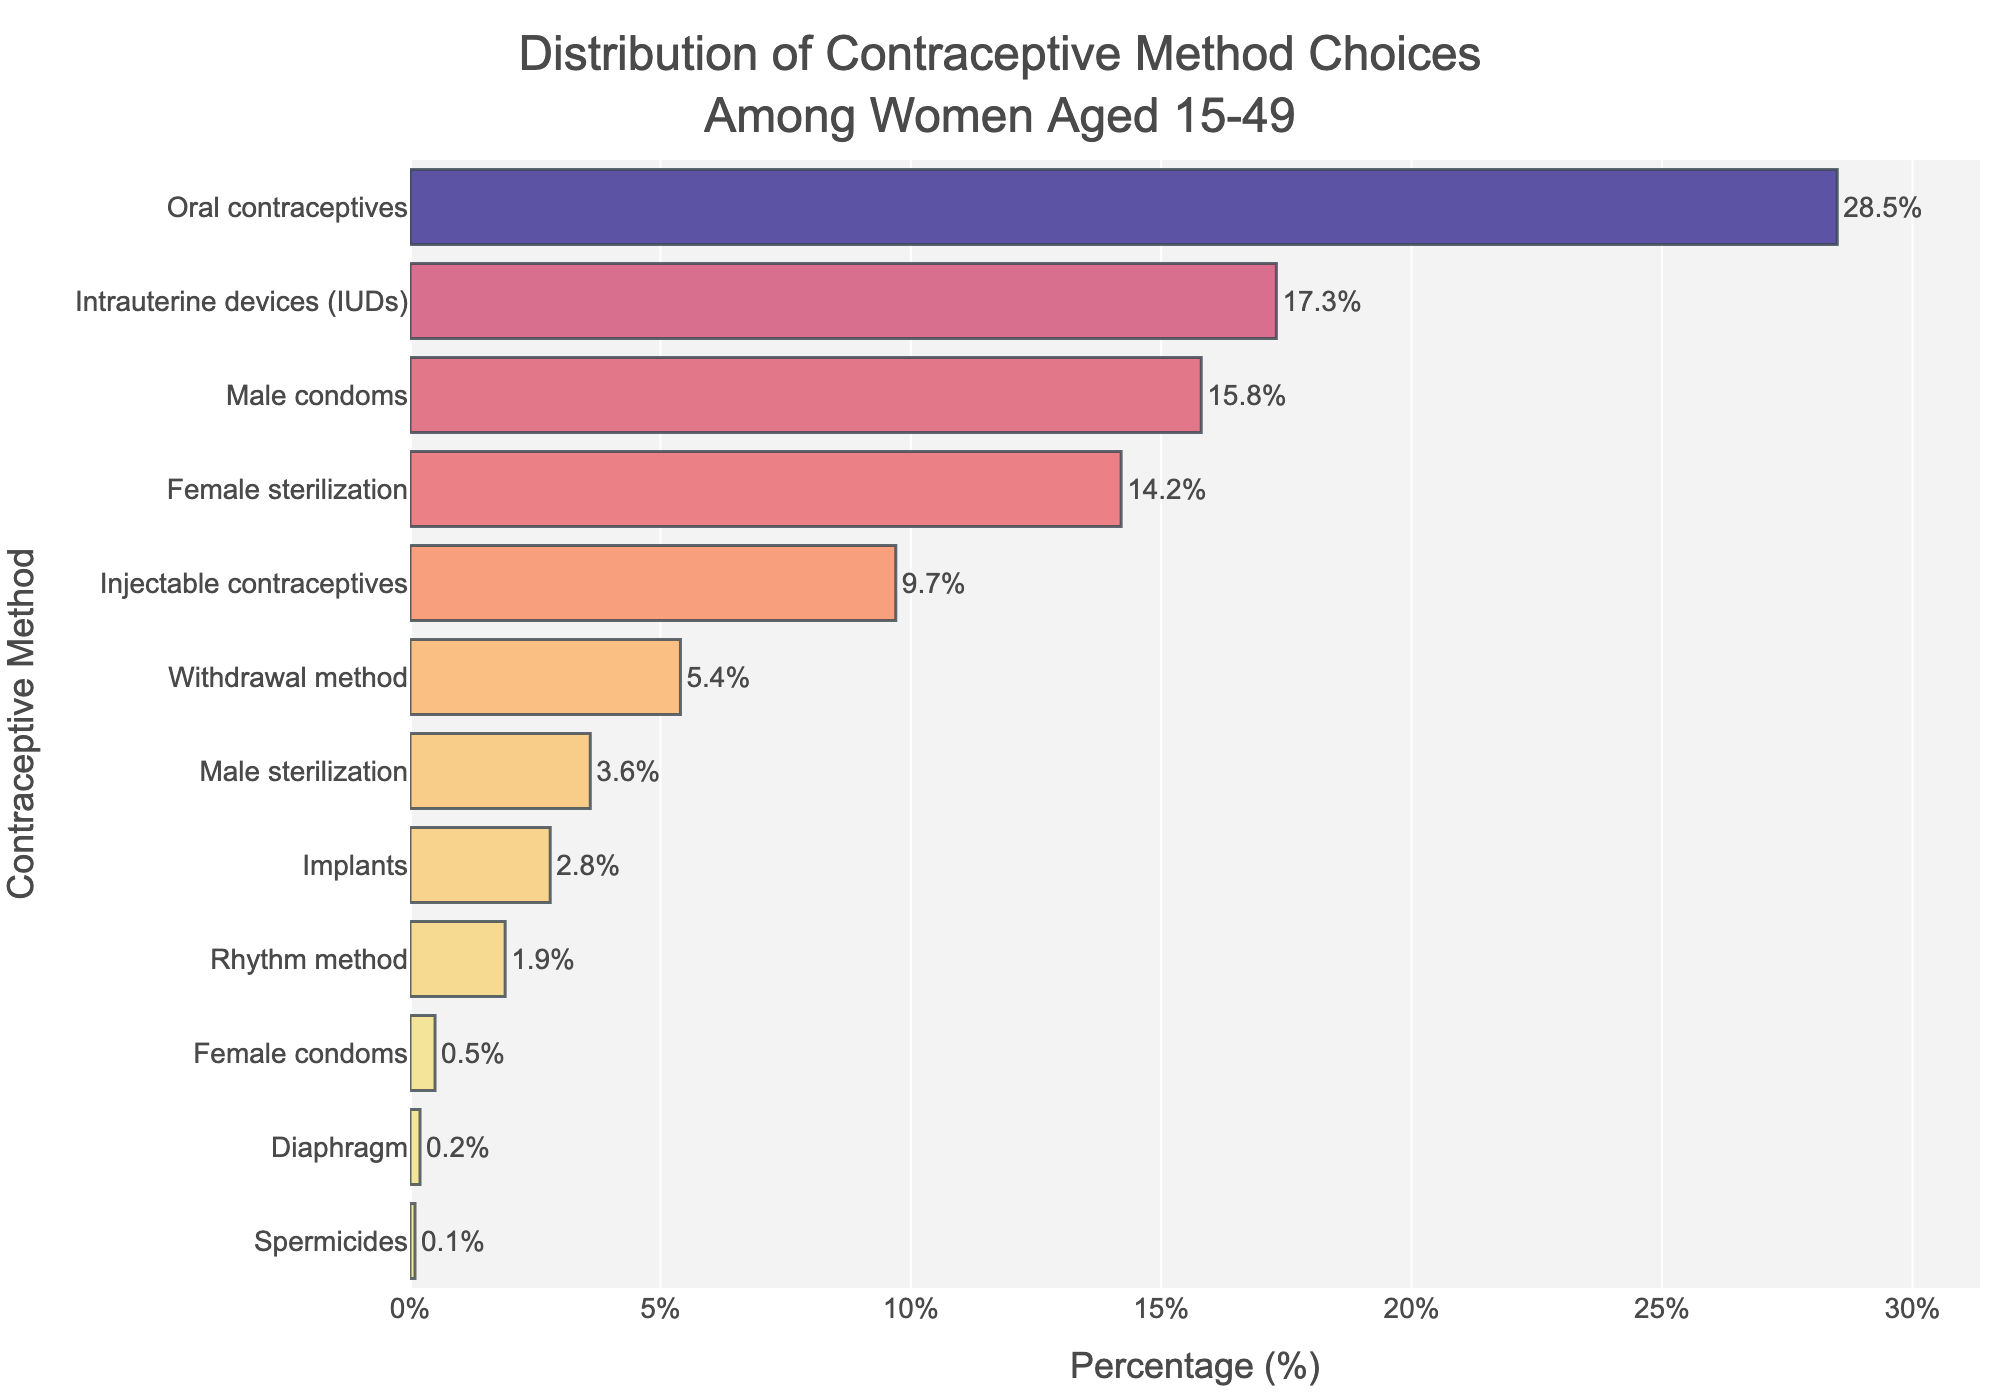Which contraceptive method is chosen by the highest percentage of women aged 15-49? The bar that reaches the farthest to the right indicates the contraceptive method chosen by the highest percentage of women. According to the chart, oral contraceptives have the highest percentage at 28.5%.
Answer: Oral contraceptives Which contraceptive method has a higher percentage of users, injectable contraceptives or intrauterine devices (IUDs)? The bar representing intrauterine devices (IUDs) is longer than the bar for injectable contraceptives. According to the chart, IUDs have 17.3% while injectable contraceptives have 9.7%.
Answer: Intrauterine devices (IUDs) What is the combined percentage of women using female sterilization, implants, and rhythm method? Sum the percentages of female sterilization (14.2%), implants (2.8%), and rhythm method (1.9%). The combined percentage is 14.2 + 2.8 + 1.9 = 18.9%.
Answer: 18.9% Compare the percentage of women using male sterilization to those using female sterilization. Which is more prevalent and by how much? Female sterilization is at 14.2% while male sterilization is at 3.6%. Subtract the percentage of male sterilization from female sterilization (14.2 - 3.6 = 10.6). Female sterilization is more prevalent by 10.6%.
Answer: Female sterilization by 10.6% Which contraceptive methods have a percentage of users less than 1%? Identify bars that reach less than 1% on the x-axis. According to the chart, female condoms (0.5%), diaphragm (0.2%), and spermicides (0.1%) are under 1%.
Answer: Female condoms, diaphragm, spermicides What is the difference in percentage between the most used method and the least used method? The most used method is oral contraceptives at 28.5% and the least used method is spermicides at 0.1%. Subtract the least from the most (28.5 - 0.1 = 28.4).
Answer: 28.4% What is the average percentage of users for male condoms and withdrawal method? Add the percentages of male condoms (15.8%) and withdrawal method (5.4%), then divide by 2. The average is (15.8 + 5.4) / 2 = 10.6%.
Answer: 10.6% By how much does the percentage of women using male condoms exceed those using implants? The percentage of male condoms users is 15.8% and for implants, it's 2.8%. Subtract the percentage of implants users from male condoms users (15.8 - 2.8 = 13).
Answer: 13% What is the combined percentage of women using oral contraceptives and male condoms? Add the percentages of oral contraceptives (28.5%) and male condoms (15.8%). The combined percentage is 28.5 + 15.8 = 44.3%.
Answer: 44.3% Which two contraceptive methods have the closest percentages of users? Compare the percentages in the chart to find the smallest difference. Male sterilization (3.6%) and implants (2.8%) have the closest percentages. The difference is 3.6 - 2.8 = 0.8%.
Answer: Male sterilization and implants 